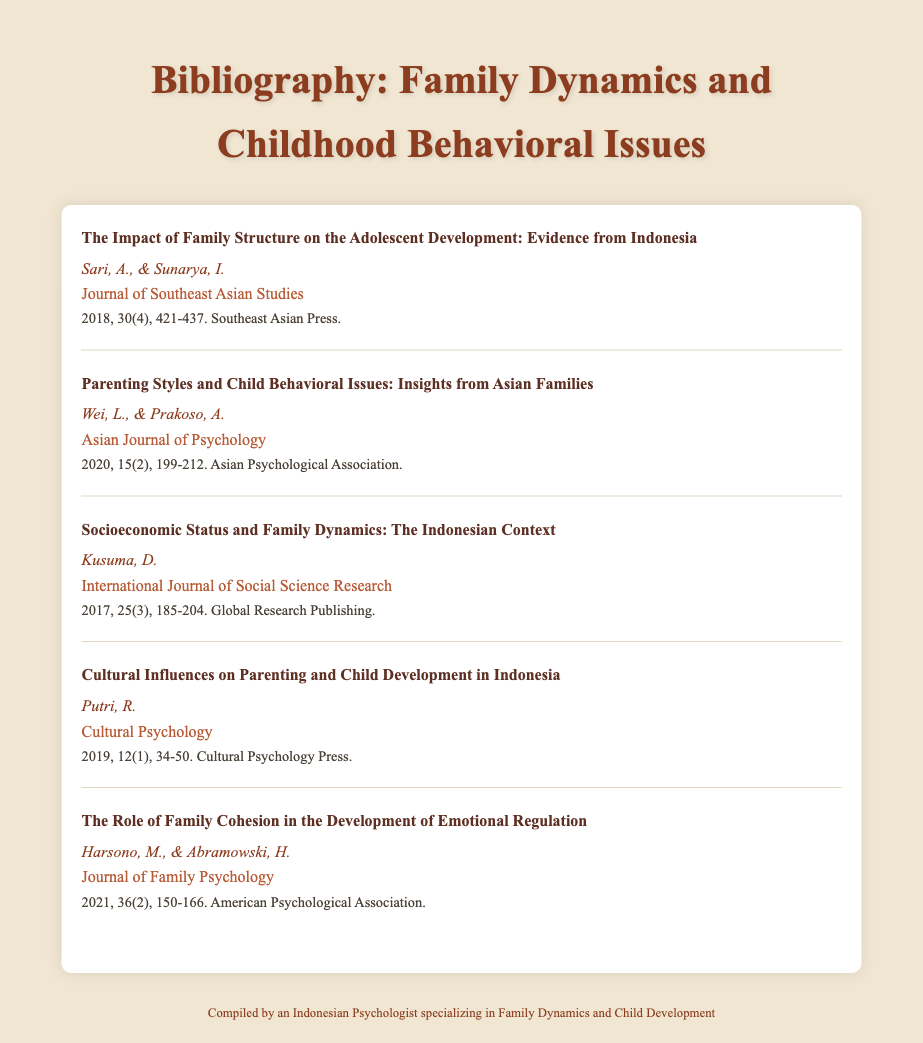What is the title of the first entry? The title of the first entry is specified in the document as "The Impact of Family Structure on the Adolescent Development: Evidence from Indonesia."
Answer: The Impact of Family Structure on the Adolescent Development: Evidence from Indonesia Who are the authors of the second entry? The authors of the second entry are mentioned in the document as Wei, L., & Prakoso, A.
Answer: Wei, L., & Prakoso, A In which journal was the fourth entry published? The journal of the fourth entry is identified in the document as Cultural Psychology.
Answer: Cultural Psychology What year was the last entry published? The year of publication for the last entry can be found in the details section of the document as 2021.
Answer: 2021 How many authors contributed to the fifth entry? The number of authors for the fifth entry is given in the document, which states Harsono, M., & Abramowski, H. As two authors.
Answer: 2 What is the volume number of the third entry? The volume number for the third entry can be determined from the details section of the document as 25.
Answer: 25 Which topic is addressed in the reference written by Kusuma, D.? The topic addressed in the entry by Kusuma, D. is about the relationship between socioeconomic status and family dynamics.
Answer: Socioeconomic Status and Family Dynamics What is the title of the journal where the second entry appeared? The title of the journal for the second entry is found in the document as Asian Journal of Psychology.
Answer: Asian Journal of Psychology 